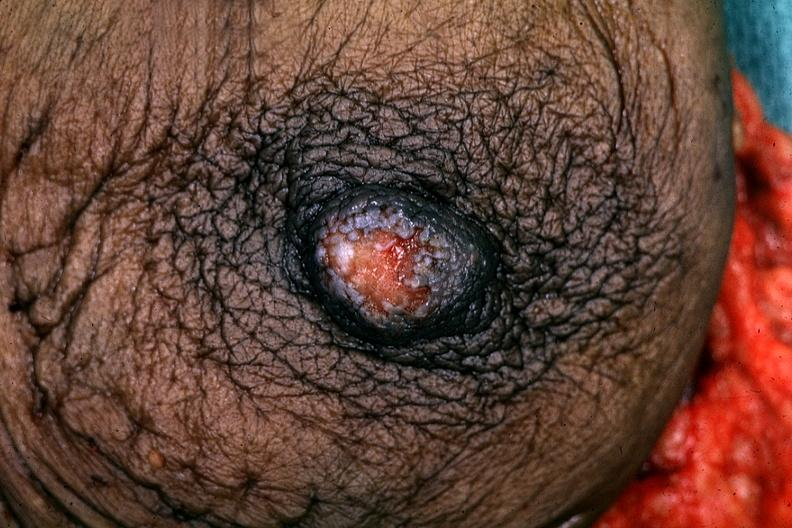where is this area in the body?
Answer the question using a single word or phrase. Breast 